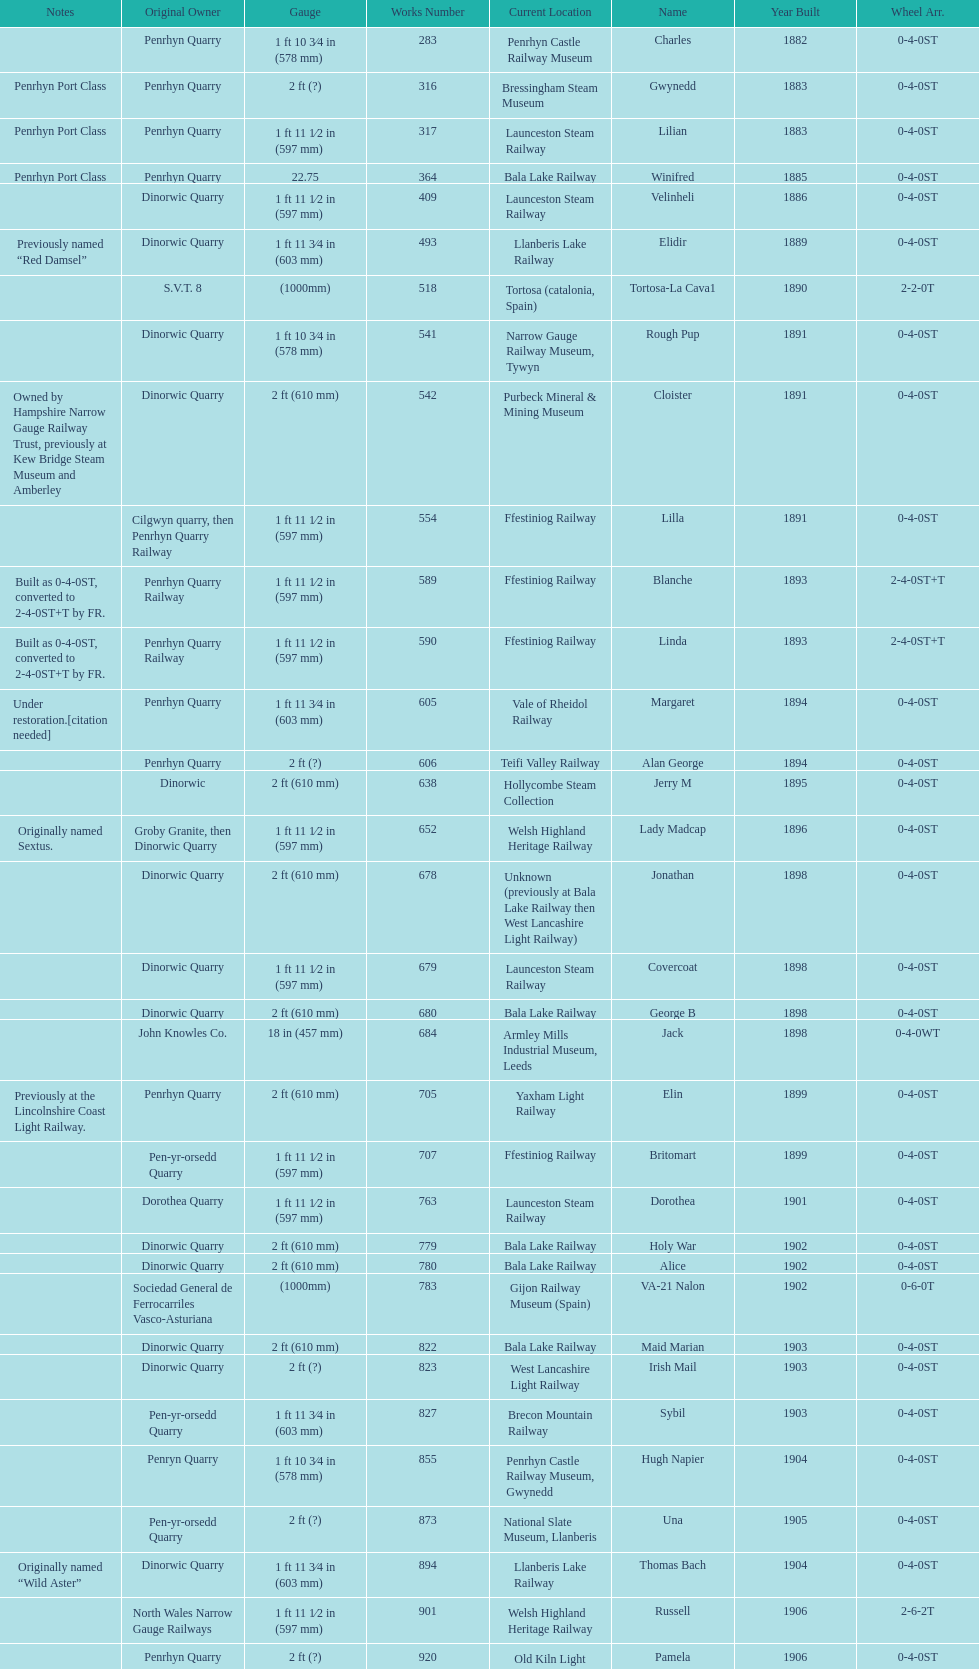Which works number had a larger gauge, 283 or 317? 317. 